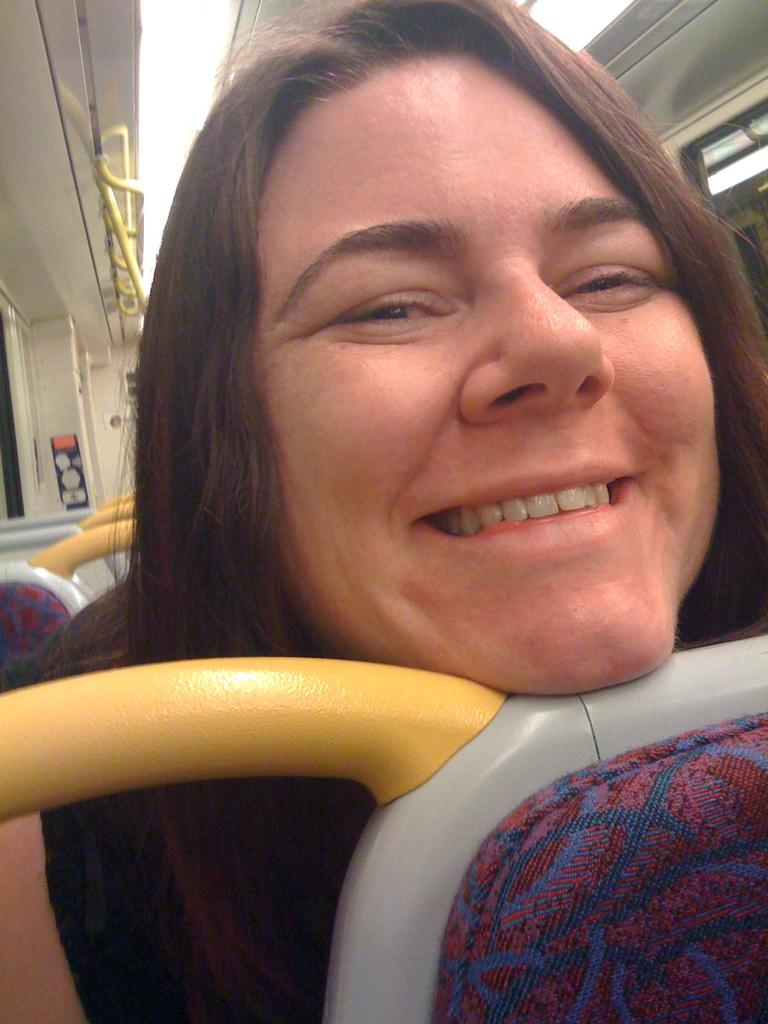What is the main subject of the image? The main subject of the image is a woman. What is the woman doing in the image? The woman is keeping her head on a seat in a vehicle. What is the woman's facial expression in the image? The woman is smiling. What type of blade can be seen in the image? There is no blade present in the image. What suggestion does the woman make in the image? The image does not depict the woman making any suggestion. 